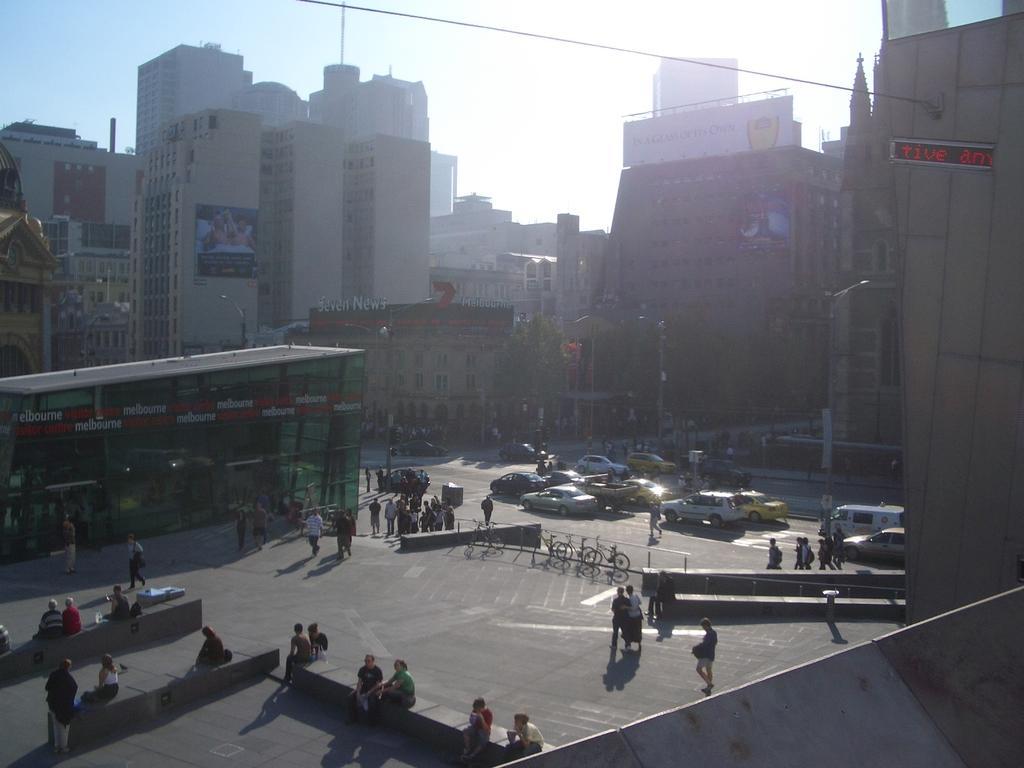How would you summarize this image in a sentence or two? In this image I can see group of people some are sitting and some are walking. I can also see few vehicles on the road, buildings in cream and white color, trees in green color, for light poles and the sky is in white color. 